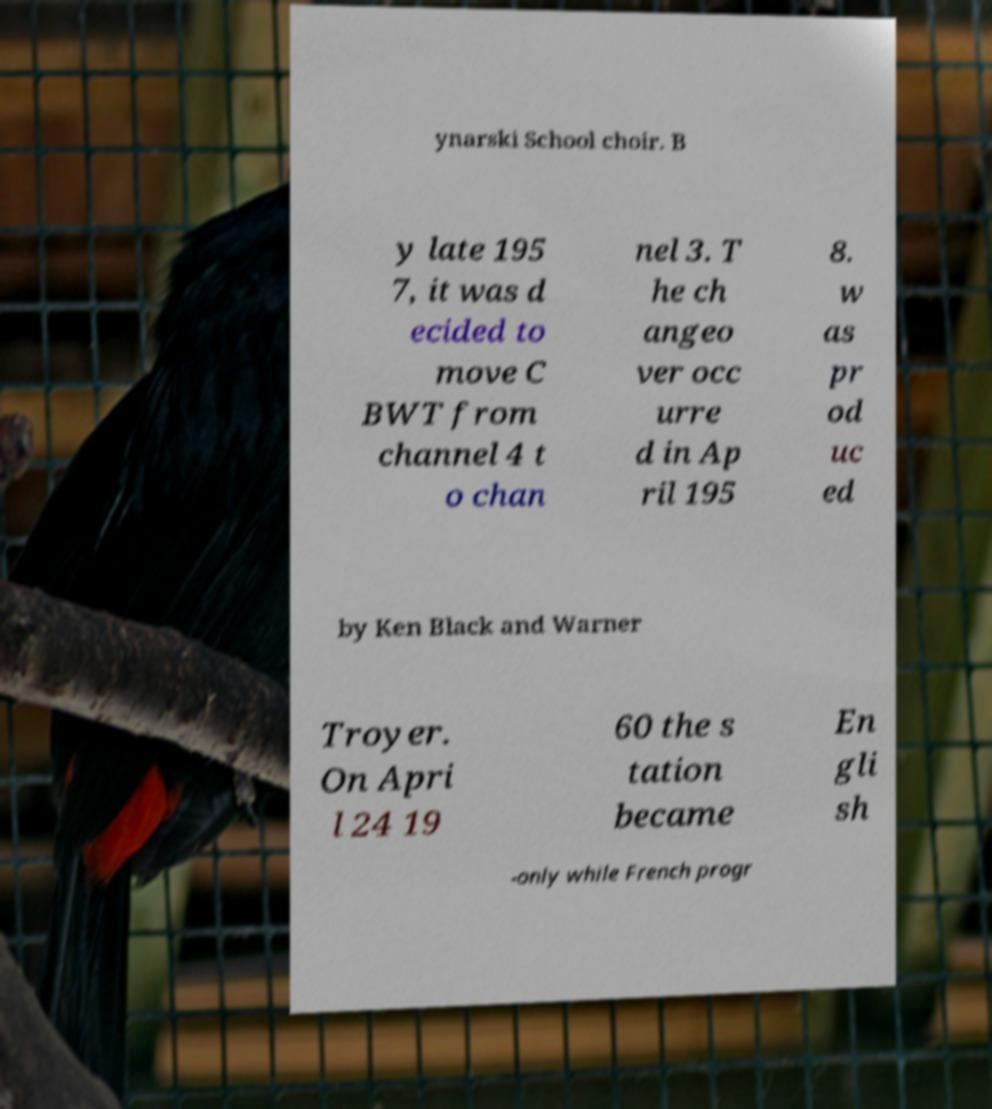Can you accurately transcribe the text from the provided image for me? ynarski School choir. B y late 195 7, it was d ecided to move C BWT from channel 4 t o chan nel 3. T he ch angeo ver occ urre d in Ap ril 195 8. w as pr od uc ed by Ken Black and Warner Troyer. On Apri l 24 19 60 the s tation became En gli sh -only while French progr 